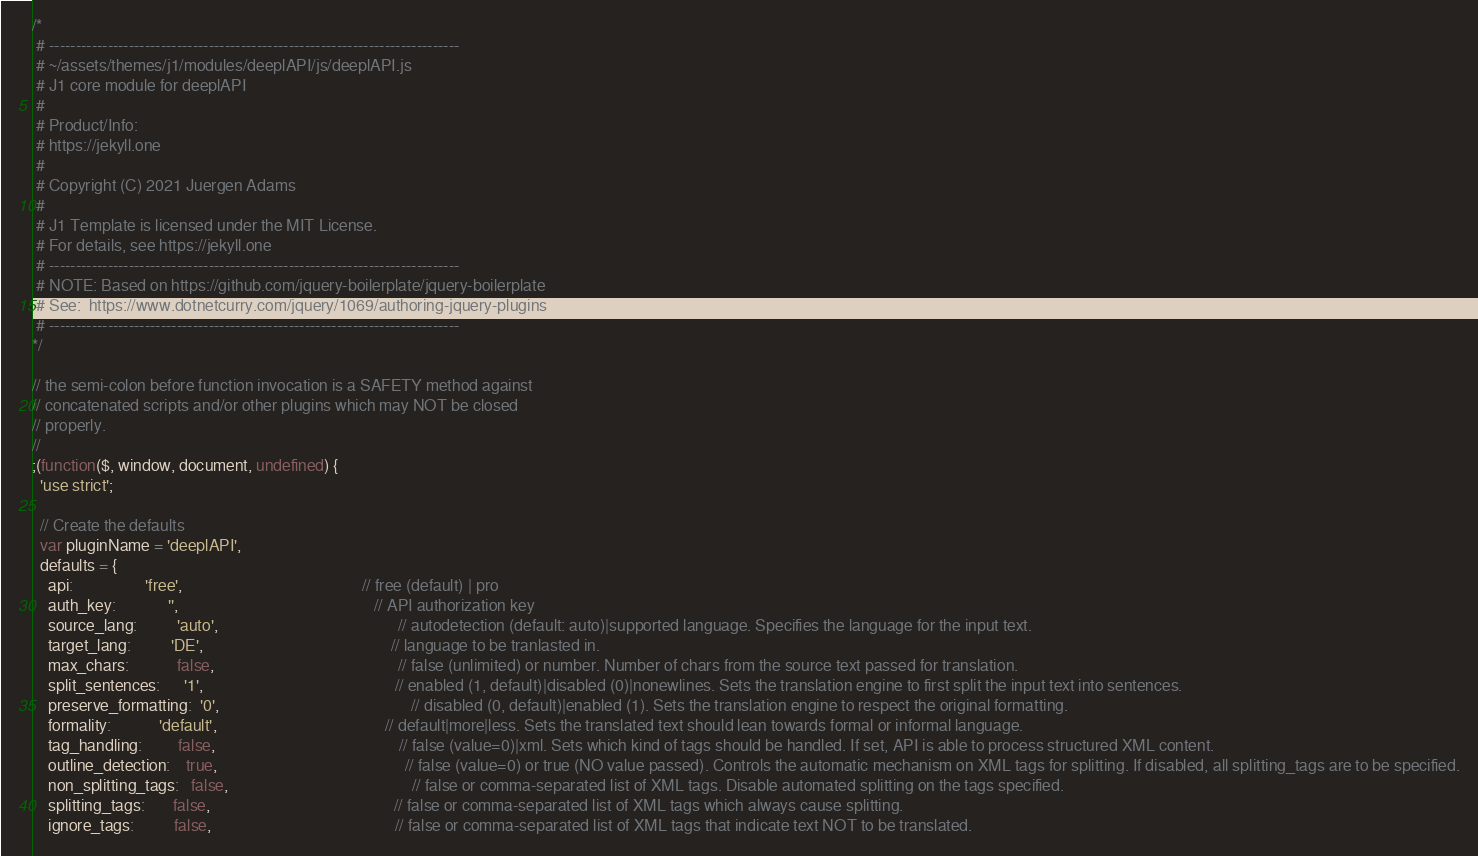Convert code to text. <code><loc_0><loc_0><loc_500><loc_500><_JavaScript_>/*
 # -----------------------------------------------------------------------------
 # ~/assets/themes/j1/modules/deeplAPI/js/deeplAPI.js
 # J1 core module for deeplAPI
 #
 # Product/Info:
 # https://jekyll.one
 #
 # Copyright (C) 2021 Juergen Adams
 #
 # J1 Template is licensed under the MIT License.
 # For details, see https://jekyll.one
 # -----------------------------------------------------------------------------
 # NOTE: Based on https://github.com/jquery-boilerplate/jquery-boilerplate
 # See:  https://www.dotnetcurry.com/jquery/1069/authoring-jquery-plugins
 # -----------------------------------------------------------------------------
*/

// the semi-colon before function invocation is a SAFETY method against
// concatenated scripts and/or other plugins which may NOT be closed
// properly.
//
;(function($, window, document, undefined) {
  'use strict';

  // Create the defaults
  var pluginName = 'deeplAPI',
  defaults = {
    api:                  'free',                                             // free (default) | pro
    auth_key:             '',                                                 // API authorization key
    source_lang:          'auto',                                             // autodetection (default: auto)|supported language. Specifies the language for the input text.
    target_lang:          'DE',                                               // language to be tranlasted in.
    max_chars:            false,                                              // false (unlimited) or number. Number of chars from the source text passed for translation.
    split_sentences:      '1',                                                // enabled (1, default)|disabled (0)|nonewlines. Sets the translation engine to first split the input text into sentences.
    preserve_formatting:  '0',                                                // disabled (0, default)|enabled (1). Sets the translation engine to respect the original formatting.
    formality:            'default',                                          // default|more|less. Sets the translated text should lean towards formal or informal language.
    tag_handling:         false,                                              // false (value=0)|xml. Sets which kind of tags should be handled. If set, API is able to process structured XML content.
    outline_detection:    true,                                               // false (value=0) or true (NO value passed). Controls the automatic mechanism on XML tags for splitting. If disabled, all splitting_tags are to be specified.
    non_splitting_tags:   false,                                              // false or comma-separated list of XML tags. Disable automated splitting on the tags specified.
    splitting_tags:       false,                                              // false or comma-separated list of XML tags which always cause splitting.
    ignore_tags:          false,                                              // false or comma-separated list of XML tags that indicate text NOT to be translated.</code> 